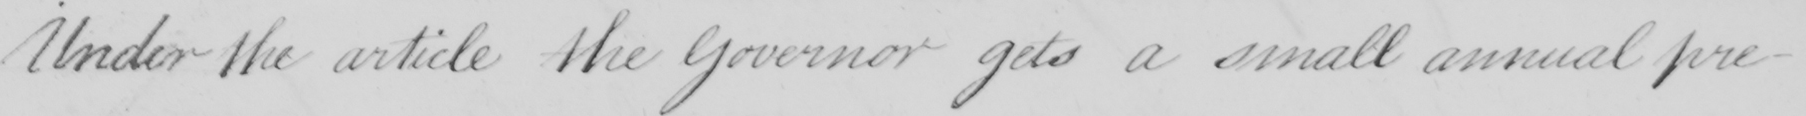What text is written in this handwritten line? Under the article the Governor gets a small annual pre- 